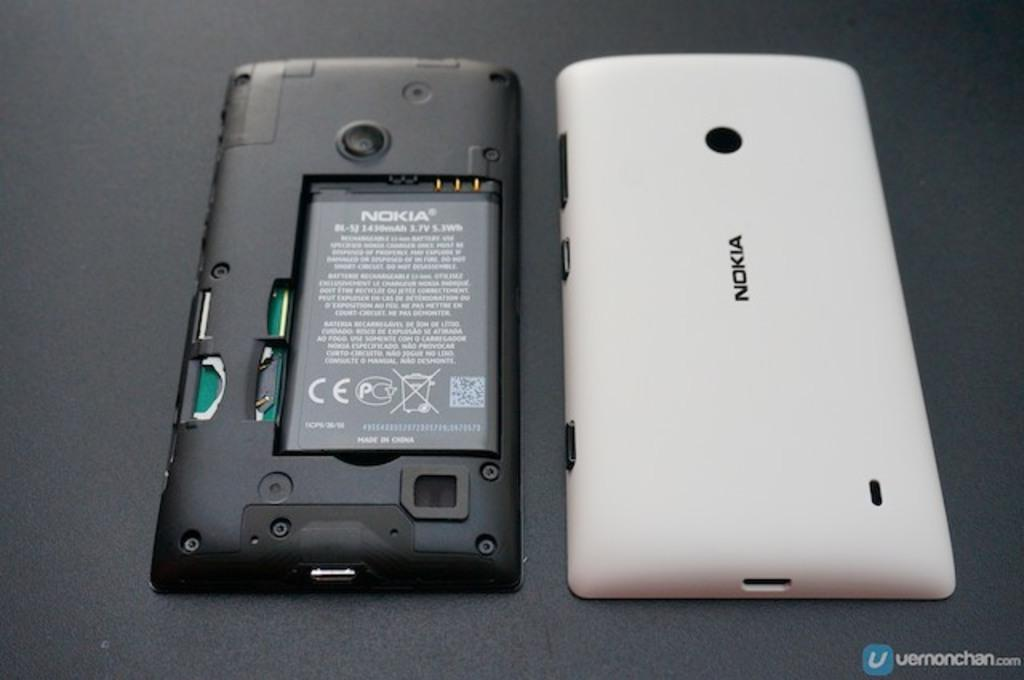<image>
Relay a brief, clear account of the picture shown. A white Nokia cellphone that has been open with the battery exposed 